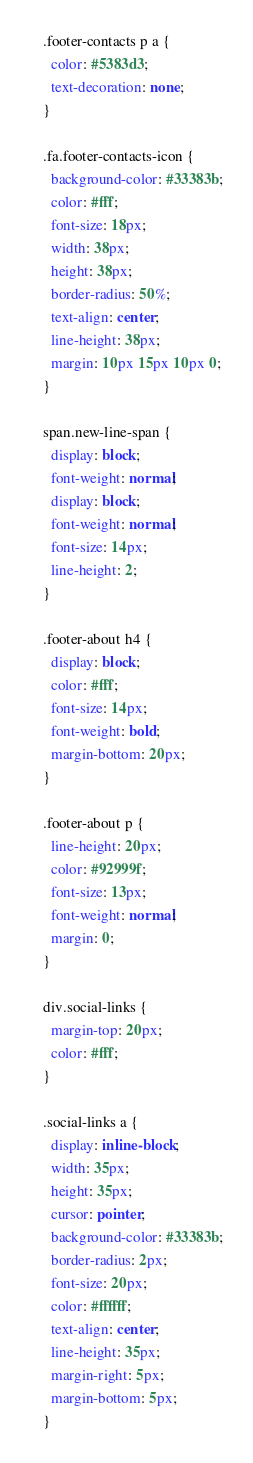<code> <loc_0><loc_0><loc_500><loc_500><_CSS_>
.footer-contacts p a {
  color: #5383d3;
  text-decoration: none;
}

.fa.footer-contacts-icon {
  background-color: #33383b;
  color: #fff;
  font-size: 18px;
  width: 38px;
  height: 38px;
  border-radius: 50%;
  text-align: center;
  line-height: 38px;
  margin: 10px 15px 10px 0;
}

span.new-line-span {
  display: block;
  font-weight: normal;
  display: block;
  font-weight: normal;
  font-size: 14px;
  line-height: 2;
}

.footer-about h4 {
  display: block;
  color: #fff;
  font-size: 14px;
  font-weight: bold;
  margin-bottom: 20px;
}

.footer-about p {
  line-height: 20px;
  color: #92999f;
  font-size: 13px;
  font-weight: normal;
  margin: 0;
}

div.social-links {
  margin-top: 20px;
  color: #fff;
}

.social-links a {
  display: inline-block;
  width: 35px;
  height: 35px;
  cursor: pointer;
  background-color: #33383b;
  border-radius: 2px;
  font-size: 20px;
  color: #ffffff;
  text-align: center;
  line-height: 35px;
  margin-right: 5px;
  margin-bottom: 5px;
}

</code> 